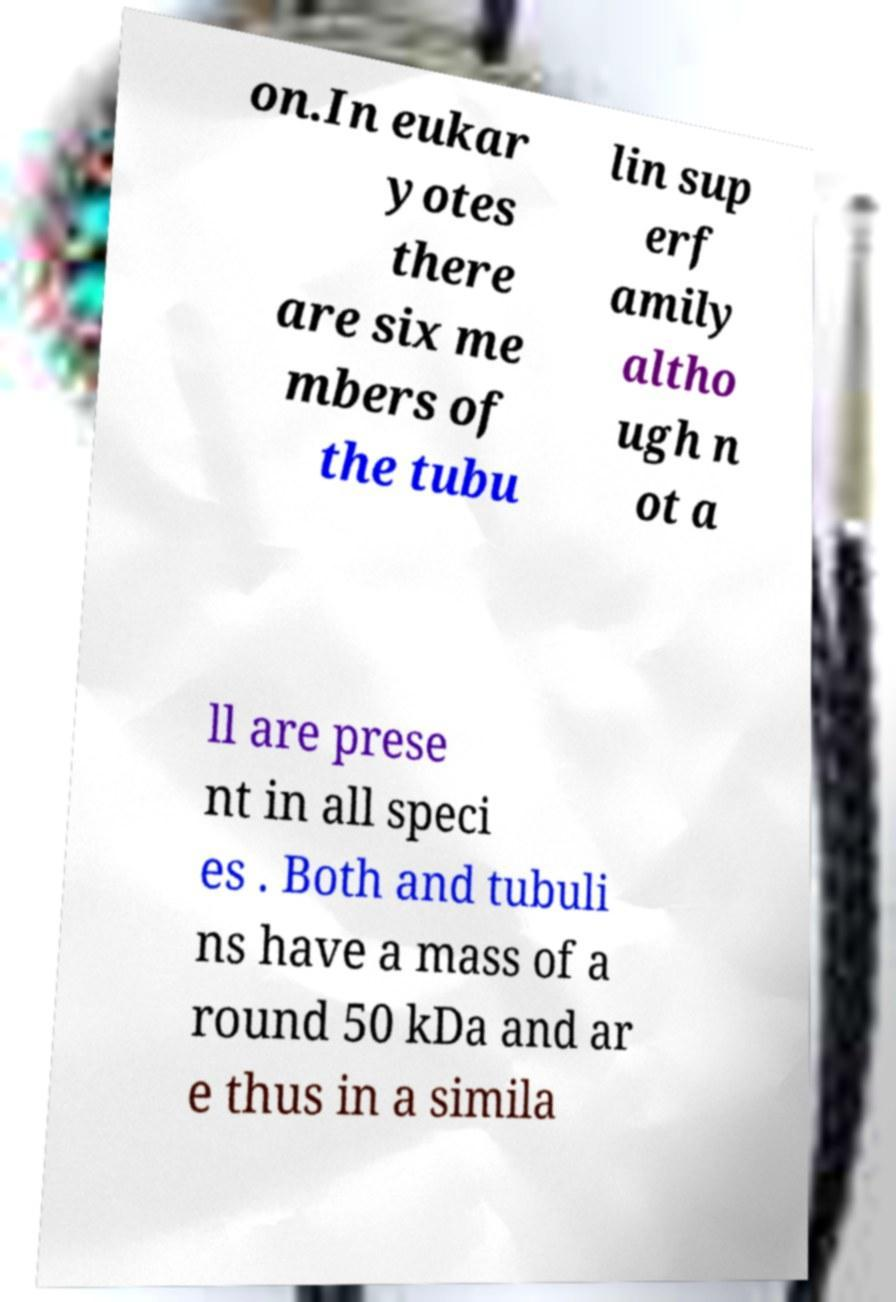For documentation purposes, I need the text within this image transcribed. Could you provide that? on.In eukar yotes there are six me mbers of the tubu lin sup erf amily altho ugh n ot a ll are prese nt in all speci es . Both and tubuli ns have a mass of a round 50 kDa and ar e thus in a simila 